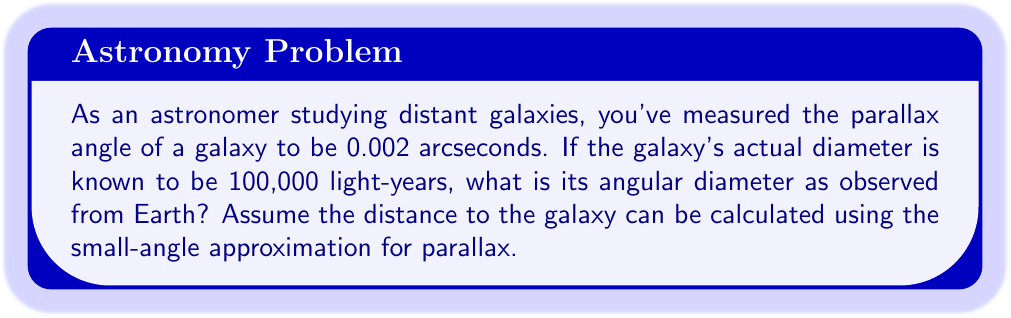Can you solve this math problem? Let's approach this step-by-step:

1) First, we need to calculate the distance to the galaxy using the parallax angle. The formula for distance using parallax is:

   $$d = \frac{1}{p}$$

   where $d$ is the distance in parsecs and $p$ is the parallax in arcseconds.

2) Given parallax $p = 0.002$ arcseconds, we can calculate the distance:

   $$d = \frac{1}{0.002} = 500 \text{ parsecs}$$

3) We need to convert this to light-years. 1 parsec ≈ 3.26 light-years, so:

   $$500 \text{ parsecs} \times 3.26 = 1630 \text{ light-years}$$

4) Now, we can use the small-angle formula to calculate the angular diameter:

   $$\theta = \frac{D}{d}$$

   where $\theta$ is the angular diameter in radians, $D$ is the actual diameter, and $d$ is the distance.

5) Plugging in our values:

   $$\theta = \frac{100,000 \text{ light-years}}{1630 \text{ light-years}} = 61.35 \text{ radians}$$

6) We need to convert this to arcseconds. There are $206,265$ arcseconds in 1 radian, so:

   $$61.35 \times 206,265 = 12,654,359 \text{ arcseconds}$$

7) To simplify, we can express this in degrees:

   $$12,654,359 \text{ arcseconds} \div 3600 = 3515.1 \text{ degrees}$$
Answer: $3515.1°$ 